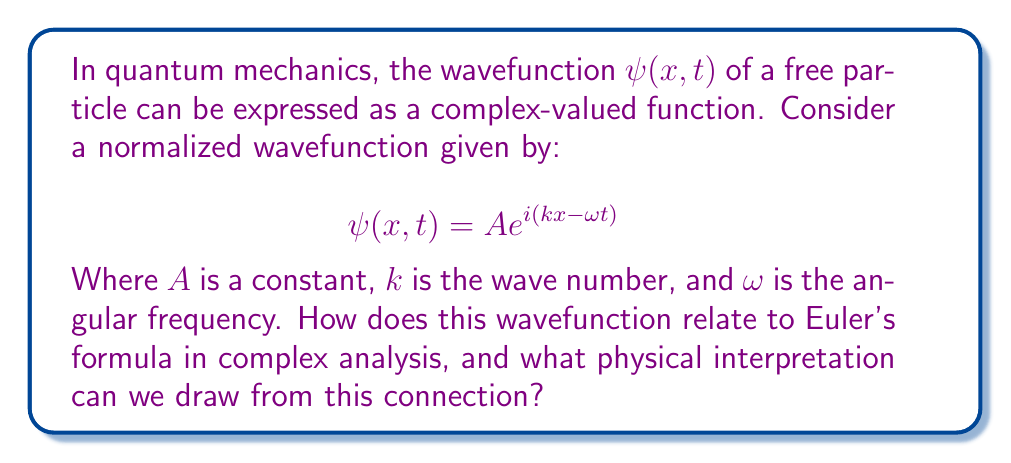Can you answer this question? 1. Recall Euler's formula from complex analysis:
   $$e^{i\theta} = \cos\theta + i\sin\theta$$

2. Apply this to our wavefunction:
   $$\psi(x,t) = A e^{i(kx-\omega t)} = A[\cos(kx-\omega t) + i\sin(kx-\omega t)]$$

3. This shows that the wavefunction has a real and imaginary part:
   $$\text{Re}[\psi(x,t)] = A\cos(kx-\omega t)$$
   $$\text{Im}[\psi(x,t)] = A\sin(kx-\omega t)$$

4. The physical interpretation:
   - The real and imaginary parts represent oscillating waves.
   - The amplitude $A$ relates to the probability of finding the particle.
   - The phase $(kx-\omega t)$ contains information about the particle's momentum and energy.

5. The complex nature allows for:
   - Superposition of states (adding wavefunctions)
   - Calculation of expectation values using complex conjugates
   - Representation of spin and other quantum properties

6. The connection to complex analysis enables:
   - Use of contour integration techniques in quantum field theory
   - Application of residue theorem in scattering theory
   - Analysis of poles and branch cuts in Green's functions

This link between complex analysis and quantum mechanics provides powerful mathematical tools for describing and analyzing quantum systems.
Answer: Euler's formula connects the complex exponential in the wavefunction to oscillating real and imaginary parts, allowing for representation of quantum superposition, probability amplitudes, and enabling powerful complex analysis techniques in quantum mechanics. 